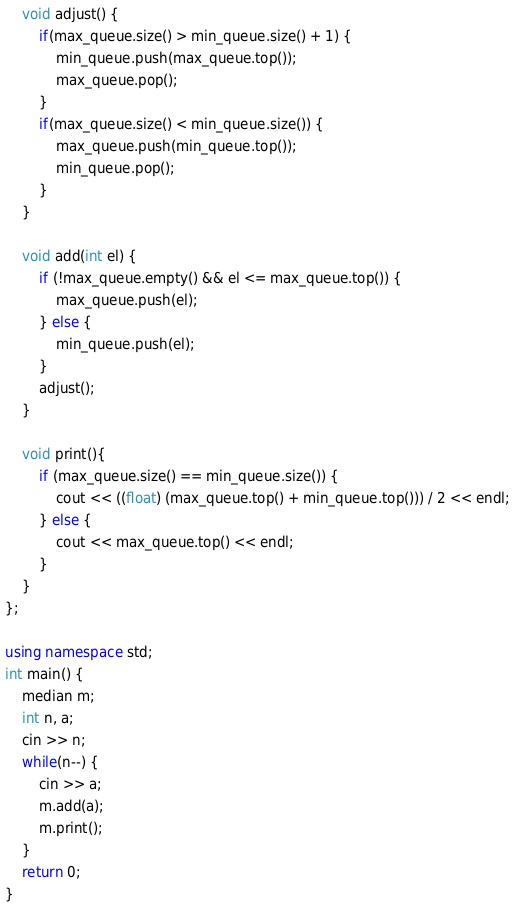<code> <loc_0><loc_0><loc_500><loc_500><_C++_>    void adjust() {
        if(max_queue.size() > min_queue.size() + 1) {
            min_queue.push(max_queue.top());
            max_queue.pop();
        }
        if(max_queue.size() < min_queue.size()) {
            max_queue.push(min_queue.top());
            min_queue.pop();
        }
    }

    void add(int el) {
        if (!max_queue.empty() && el <= max_queue.top()) {
            max_queue.push(el);
        } else {
            min_queue.push(el);
        }
        adjust();
    }

    void print(){
        if (max_queue.size() == min_queue.size()) {
            cout << ((float) (max_queue.top() + min_queue.top())) / 2 << endl;
        } else {
            cout << max_queue.top() << endl;
        }
    }
};

using namespace std;
int main() {
    median m;
    int n, a;
    cin >> n;
    while(n--) {
        cin >> a;
        m.add(a);
        m.print();
    }
    return 0;
}
</code> 